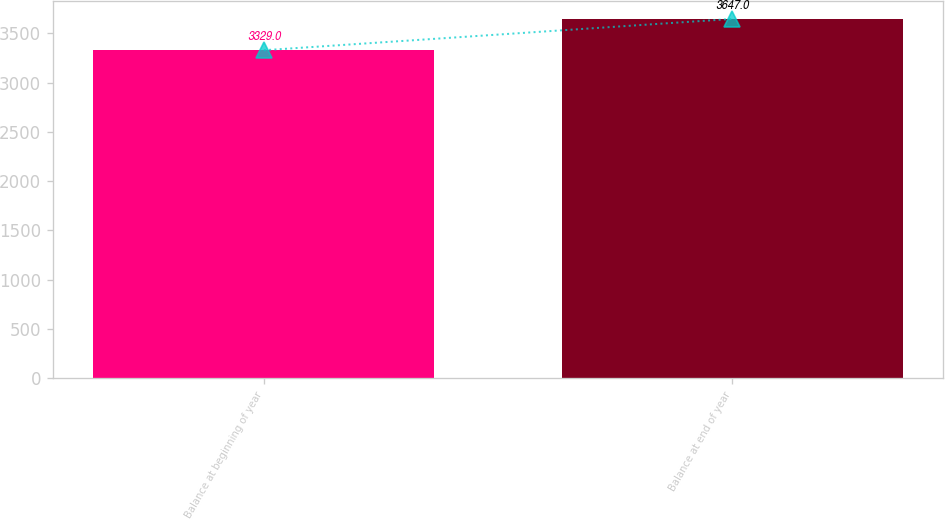<chart> <loc_0><loc_0><loc_500><loc_500><bar_chart><fcel>Balance at beginning of year<fcel>Balance at end of year<nl><fcel>3329<fcel>3647<nl></chart> 